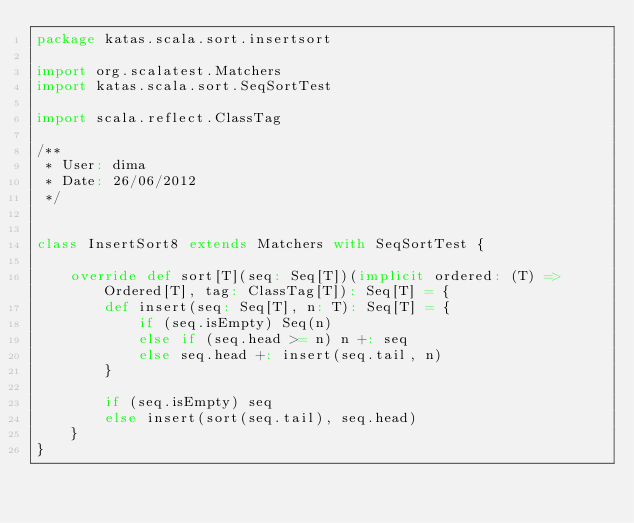Convert code to text. <code><loc_0><loc_0><loc_500><loc_500><_Scala_>package katas.scala.sort.insertsort

import org.scalatest.Matchers
import katas.scala.sort.SeqSortTest

import scala.reflect.ClassTag

/**
 * User: dima
 * Date: 26/06/2012
 */


class InsertSort8 extends Matchers with SeqSortTest {

	override def sort[T](seq: Seq[T])(implicit ordered: (T) => Ordered[T], tag: ClassTag[T]): Seq[T] = {
		def insert(seq: Seq[T], n: T): Seq[T] = {
			if (seq.isEmpty) Seq(n)
			else if (seq.head >= n) n +: seq
			else seq.head +: insert(seq.tail, n)
		}

		if (seq.isEmpty) seq
		else insert(sort(seq.tail), seq.head)
	}
}</code> 